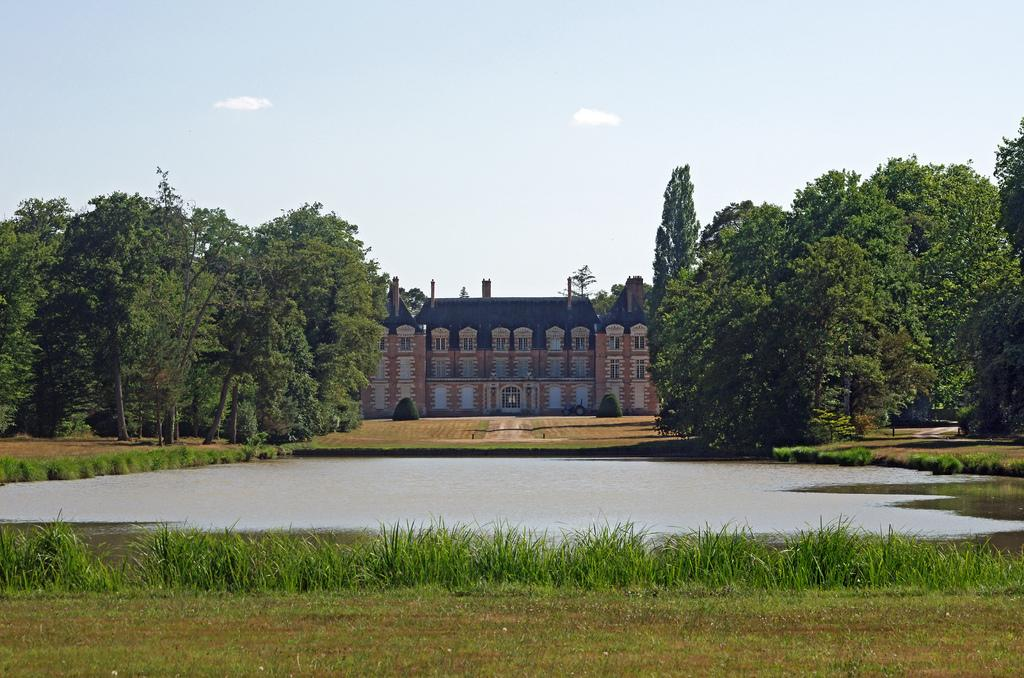What type of vegetation can be seen in the image? There is grass in the image. What natural element is also visible in the image? There is water visible in the image. What can be seen in the background of the image? There is a building, trees, and the sky visible in the background of the image. What type of nail can be seen in the image? There is no nail present in the image. What color is the silver crook in the image? There is no silver crook present in the image. 